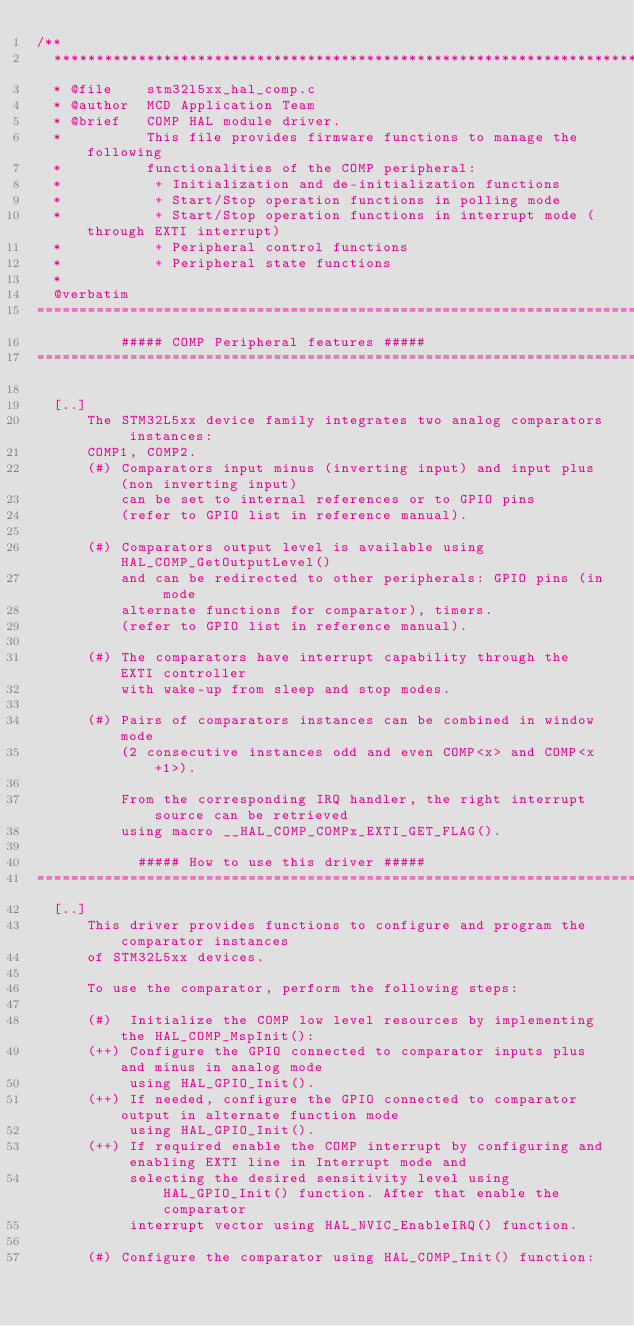<code> <loc_0><loc_0><loc_500><loc_500><_C_>/**
  ******************************************************************************
  * @file    stm32l5xx_hal_comp.c
  * @author  MCD Application Team
  * @brief   COMP HAL module driver.
  *          This file provides firmware functions to manage the following
  *          functionalities of the COMP peripheral:
  *           + Initialization and de-initialization functions
  *           + Start/Stop operation functions in polling mode
  *           + Start/Stop operation functions in interrupt mode (through EXTI interrupt)
  *           + Peripheral control functions
  *           + Peripheral state functions
  *
  @verbatim
================================================================================
          ##### COMP Peripheral features #####
================================================================================

  [..]
      The STM32L5xx device family integrates two analog comparators instances:
      COMP1, COMP2.
      (#) Comparators input minus (inverting input) and input plus (non inverting input)
          can be set to internal references or to GPIO pins
          (refer to GPIO list in reference manual).

      (#) Comparators output level is available using HAL_COMP_GetOutputLevel()
          and can be redirected to other peripherals: GPIO pins (in mode
          alternate functions for comparator), timers.
          (refer to GPIO list in reference manual).

      (#) The comparators have interrupt capability through the EXTI controller
          with wake-up from sleep and stop modes.

      (#) Pairs of comparators instances can be combined in window mode
          (2 consecutive instances odd and even COMP<x> and COMP<x+1>).

          From the corresponding IRQ handler, the right interrupt source can be retrieved
          using macro __HAL_COMP_COMPx_EXTI_GET_FLAG().

            ##### How to use this driver #####
================================================================================
  [..]
      This driver provides functions to configure and program the comparator instances
      of STM32L5xx devices.

      To use the comparator, perform the following steps:

      (#)  Initialize the COMP low level resources by implementing the HAL_COMP_MspInit():
      (++) Configure the GPIO connected to comparator inputs plus and minus in analog mode
           using HAL_GPIO_Init().
      (++) If needed, configure the GPIO connected to comparator output in alternate function mode
           using HAL_GPIO_Init().
      (++) If required enable the COMP interrupt by configuring and enabling EXTI line in Interrupt mode and
           selecting the desired sensitivity level using HAL_GPIO_Init() function. After that enable the comparator
           interrupt vector using HAL_NVIC_EnableIRQ() function.

      (#) Configure the comparator using HAL_COMP_Init() function:</code> 